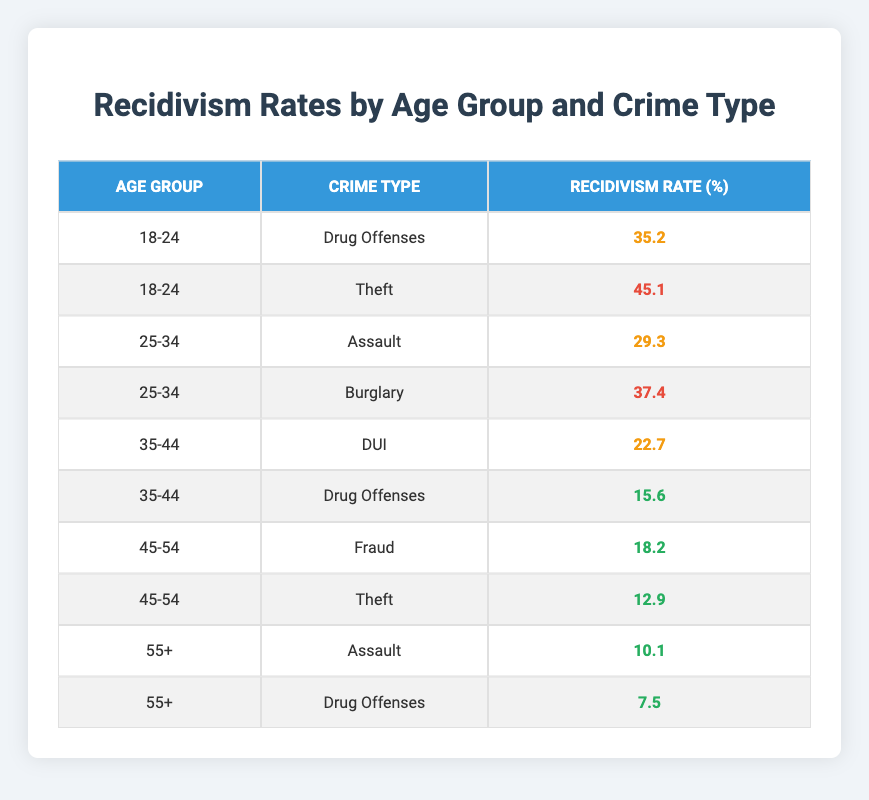What is the recidivism rate for Drug Offenses in the age group 18-24? The table shows that the recidivism rate for Drug Offenses in the age group 18-24 is 35.2%.
Answer: 35.2 Which age group has the highest recidivism rate for Theft? According to the table, the age group 18-24 has a recidivism rate of 45.1% for Theft, which is higher than any other age group.
Answer: 18-24 How many crime types have a recidivism rate below 20%? The table indicates that the crime types with rates below 20% are Drug Offenses for the age group 35-44 at 15.6%, Fraud for 45-54 at 18.2%, and Theft for 45-54 at 12.9%. That makes a total of three crime types with rates below 20%.
Answer: 3 What is the average recidivism rate for the age group 25-34? The recidivism rates for the age group 25-34 are 29.3% for Assault and 37.4% for Burglary. Summing these gives 29.3 + 37.4 = 66.7. Dividing by 2 gives an average recidivism rate of 33.35%.
Answer: 33.35 Is the recidivism rate for Assault higher for clients aged 18-24 or clients aged 55+? The table shows that clients aged 18-24 have a recidivism rate for Assault of 45.1%, while those aged 55+ have a rate of 10.1%. Clearly, 45.1% is higher than 10.1%.
Answer: Yes Which crime type has the lowest recidivism rate among all age groups? The table indicates that Drug Offenses in the age group 55+ has the lowest recidivism rate at 7.5%.
Answer: 7.5 Are recidivism rates generally lower for older age groups compared to younger ones? By comparing recidivism rates across the age groups, the older age groups (35-44, 45-54, 55+) generally show lower rates compared to the younger groups (18-24, 25-34). This suggests that recidivism rates are indeed lower for older individuals.
Answer: Yes What is the difference in recidivism rates for Theft between age groups 18-24 and 45-54? The recidivism rate for Theft in the age group 18-24 is 45.1%, and in the age group 45-54, it is 12.9%. The difference is 45.1 - 12.9 = 32.2%.
Answer: 32.2 